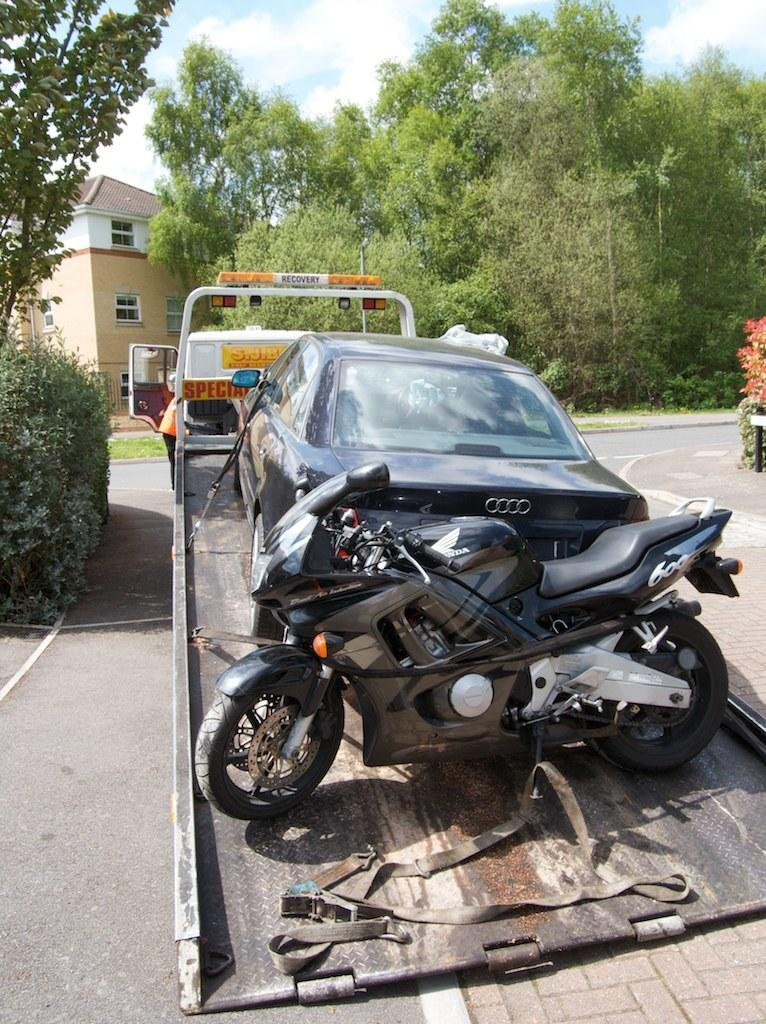What type of vehicle is in the image? There is a truck in the image. What is the truck carrying? The truck is carrying a bike and a bike and a car. Where is the truck located in the image? The truck is on the road. What structure is on the left side of the image? There is a building on the left side of the image. What can be seen in front of the building? There are trees in front of the building. What type of feather can be seen on the brake of the car in the image? There is no feather visible on the brake of the car in the image. What parcel is being delivered by the truck in the image? The image does not show any parcels being delivered by the truck; it only shows the truck carrying a bike and a car. 